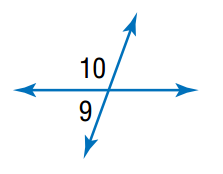Answer the mathemtical geometry problem and directly provide the correct option letter.
Question: m \angle 9 = 2 x - 4, m \angle 10 = 2 x + 4. Find the measure of \angle 9.
Choices: A: 45 B: 82 C: 86 D: 94 C 